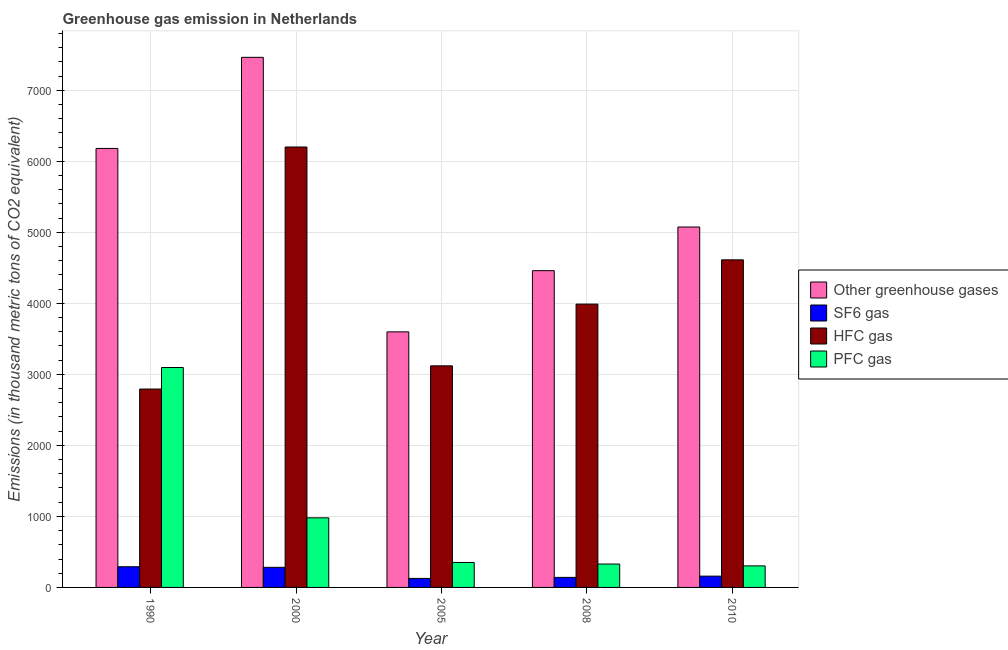Are the number of bars per tick equal to the number of legend labels?
Your answer should be compact. Yes. Are the number of bars on each tick of the X-axis equal?
Your response must be concise. Yes. How many bars are there on the 3rd tick from the right?
Provide a succinct answer. 4. What is the label of the 3rd group of bars from the left?
Give a very brief answer. 2005. In how many cases, is the number of bars for a given year not equal to the number of legend labels?
Keep it short and to the point. 0. What is the emission of hfc gas in 2005?
Provide a succinct answer. 3119.5. Across all years, what is the maximum emission of greenhouse gases?
Make the answer very short. 7462.9. Across all years, what is the minimum emission of hfc gas?
Your response must be concise. 2792.9. In which year was the emission of greenhouse gases maximum?
Your answer should be compact. 2000. In which year was the emission of sf6 gas minimum?
Offer a very short reply. 2005. What is the total emission of sf6 gas in the graph?
Keep it short and to the point. 1001.6. What is the difference between the emission of sf6 gas in 2000 and that in 2005?
Keep it short and to the point. 156.1. What is the difference between the emission of sf6 gas in 2005 and the emission of greenhouse gases in 2010?
Your answer should be compact. -32.1. What is the average emission of greenhouse gases per year?
Keep it short and to the point. 5354.9. In the year 2005, what is the difference between the emission of pfc gas and emission of hfc gas?
Offer a terse response. 0. What is the ratio of the emission of sf6 gas in 2000 to that in 2005?
Keep it short and to the point. 2.23. Is the emission of hfc gas in 2005 less than that in 2010?
Provide a short and direct response. Yes. Is the difference between the emission of pfc gas in 2005 and 2008 greater than the difference between the emission of greenhouse gases in 2005 and 2008?
Ensure brevity in your answer.  No. What is the difference between the highest and the second highest emission of pfc gas?
Your answer should be very brief. 2116.7. What is the difference between the highest and the lowest emission of hfc gas?
Keep it short and to the point. 3407.5. In how many years, is the emission of greenhouse gases greater than the average emission of greenhouse gases taken over all years?
Keep it short and to the point. 2. Is the sum of the emission of pfc gas in 2005 and 2010 greater than the maximum emission of sf6 gas across all years?
Your answer should be very brief. No. Is it the case that in every year, the sum of the emission of greenhouse gases and emission of hfc gas is greater than the sum of emission of pfc gas and emission of sf6 gas?
Offer a terse response. Yes. What does the 2nd bar from the left in 2010 represents?
Keep it short and to the point. SF6 gas. What does the 4th bar from the right in 2008 represents?
Your answer should be very brief. Other greenhouse gases. Are all the bars in the graph horizontal?
Ensure brevity in your answer.  No. How many years are there in the graph?
Keep it short and to the point. 5. What is the difference between two consecutive major ticks on the Y-axis?
Provide a succinct answer. 1000. Are the values on the major ticks of Y-axis written in scientific E-notation?
Provide a succinct answer. No. Does the graph contain grids?
Your answer should be compact. Yes. Where does the legend appear in the graph?
Your answer should be compact. Center right. How are the legend labels stacked?
Provide a succinct answer. Vertical. What is the title of the graph?
Give a very brief answer. Greenhouse gas emission in Netherlands. What is the label or title of the Y-axis?
Offer a very short reply. Emissions (in thousand metric tons of CO2 equivalent). What is the Emissions (in thousand metric tons of CO2 equivalent) in Other greenhouse gases in 1990?
Your answer should be very brief. 6180.4. What is the Emissions (in thousand metric tons of CO2 equivalent) of SF6 gas in 1990?
Provide a short and direct response. 291.3. What is the Emissions (in thousand metric tons of CO2 equivalent) of HFC gas in 1990?
Offer a very short reply. 2792.9. What is the Emissions (in thousand metric tons of CO2 equivalent) in PFC gas in 1990?
Offer a terse response. 3096.2. What is the Emissions (in thousand metric tons of CO2 equivalent) in Other greenhouse gases in 2000?
Give a very brief answer. 7462.9. What is the Emissions (in thousand metric tons of CO2 equivalent) of SF6 gas in 2000?
Give a very brief answer. 283. What is the Emissions (in thousand metric tons of CO2 equivalent) of HFC gas in 2000?
Provide a short and direct response. 6200.4. What is the Emissions (in thousand metric tons of CO2 equivalent) in PFC gas in 2000?
Offer a very short reply. 979.5. What is the Emissions (in thousand metric tons of CO2 equivalent) of Other greenhouse gases in 2005?
Your response must be concise. 3597.8. What is the Emissions (in thousand metric tons of CO2 equivalent) of SF6 gas in 2005?
Offer a very short reply. 126.9. What is the Emissions (in thousand metric tons of CO2 equivalent) of HFC gas in 2005?
Provide a short and direct response. 3119.5. What is the Emissions (in thousand metric tons of CO2 equivalent) in PFC gas in 2005?
Provide a succinct answer. 351.4. What is the Emissions (in thousand metric tons of CO2 equivalent) of Other greenhouse gases in 2008?
Give a very brief answer. 4459.4. What is the Emissions (in thousand metric tons of CO2 equivalent) of SF6 gas in 2008?
Give a very brief answer. 141.4. What is the Emissions (in thousand metric tons of CO2 equivalent) in HFC gas in 2008?
Offer a terse response. 3988.8. What is the Emissions (in thousand metric tons of CO2 equivalent) of PFC gas in 2008?
Ensure brevity in your answer.  329.2. What is the Emissions (in thousand metric tons of CO2 equivalent) in Other greenhouse gases in 2010?
Provide a succinct answer. 5074. What is the Emissions (in thousand metric tons of CO2 equivalent) in SF6 gas in 2010?
Offer a very short reply. 159. What is the Emissions (in thousand metric tons of CO2 equivalent) of HFC gas in 2010?
Your response must be concise. 4612. What is the Emissions (in thousand metric tons of CO2 equivalent) in PFC gas in 2010?
Provide a succinct answer. 303. Across all years, what is the maximum Emissions (in thousand metric tons of CO2 equivalent) in Other greenhouse gases?
Your answer should be very brief. 7462.9. Across all years, what is the maximum Emissions (in thousand metric tons of CO2 equivalent) in SF6 gas?
Your response must be concise. 291.3. Across all years, what is the maximum Emissions (in thousand metric tons of CO2 equivalent) of HFC gas?
Your response must be concise. 6200.4. Across all years, what is the maximum Emissions (in thousand metric tons of CO2 equivalent) in PFC gas?
Offer a very short reply. 3096.2. Across all years, what is the minimum Emissions (in thousand metric tons of CO2 equivalent) of Other greenhouse gases?
Offer a terse response. 3597.8. Across all years, what is the minimum Emissions (in thousand metric tons of CO2 equivalent) of SF6 gas?
Your response must be concise. 126.9. Across all years, what is the minimum Emissions (in thousand metric tons of CO2 equivalent) in HFC gas?
Make the answer very short. 2792.9. Across all years, what is the minimum Emissions (in thousand metric tons of CO2 equivalent) in PFC gas?
Keep it short and to the point. 303. What is the total Emissions (in thousand metric tons of CO2 equivalent) of Other greenhouse gases in the graph?
Make the answer very short. 2.68e+04. What is the total Emissions (in thousand metric tons of CO2 equivalent) of SF6 gas in the graph?
Make the answer very short. 1001.6. What is the total Emissions (in thousand metric tons of CO2 equivalent) in HFC gas in the graph?
Give a very brief answer. 2.07e+04. What is the total Emissions (in thousand metric tons of CO2 equivalent) of PFC gas in the graph?
Provide a short and direct response. 5059.3. What is the difference between the Emissions (in thousand metric tons of CO2 equivalent) in Other greenhouse gases in 1990 and that in 2000?
Your answer should be compact. -1282.5. What is the difference between the Emissions (in thousand metric tons of CO2 equivalent) of SF6 gas in 1990 and that in 2000?
Your answer should be very brief. 8.3. What is the difference between the Emissions (in thousand metric tons of CO2 equivalent) in HFC gas in 1990 and that in 2000?
Keep it short and to the point. -3407.5. What is the difference between the Emissions (in thousand metric tons of CO2 equivalent) in PFC gas in 1990 and that in 2000?
Give a very brief answer. 2116.7. What is the difference between the Emissions (in thousand metric tons of CO2 equivalent) in Other greenhouse gases in 1990 and that in 2005?
Your response must be concise. 2582.6. What is the difference between the Emissions (in thousand metric tons of CO2 equivalent) in SF6 gas in 1990 and that in 2005?
Keep it short and to the point. 164.4. What is the difference between the Emissions (in thousand metric tons of CO2 equivalent) in HFC gas in 1990 and that in 2005?
Provide a succinct answer. -326.6. What is the difference between the Emissions (in thousand metric tons of CO2 equivalent) of PFC gas in 1990 and that in 2005?
Provide a short and direct response. 2744.8. What is the difference between the Emissions (in thousand metric tons of CO2 equivalent) in Other greenhouse gases in 1990 and that in 2008?
Your answer should be compact. 1721. What is the difference between the Emissions (in thousand metric tons of CO2 equivalent) of SF6 gas in 1990 and that in 2008?
Keep it short and to the point. 149.9. What is the difference between the Emissions (in thousand metric tons of CO2 equivalent) of HFC gas in 1990 and that in 2008?
Offer a terse response. -1195.9. What is the difference between the Emissions (in thousand metric tons of CO2 equivalent) of PFC gas in 1990 and that in 2008?
Provide a short and direct response. 2767. What is the difference between the Emissions (in thousand metric tons of CO2 equivalent) of Other greenhouse gases in 1990 and that in 2010?
Provide a succinct answer. 1106.4. What is the difference between the Emissions (in thousand metric tons of CO2 equivalent) in SF6 gas in 1990 and that in 2010?
Ensure brevity in your answer.  132.3. What is the difference between the Emissions (in thousand metric tons of CO2 equivalent) of HFC gas in 1990 and that in 2010?
Give a very brief answer. -1819.1. What is the difference between the Emissions (in thousand metric tons of CO2 equivalent) of PFC gas in 1990 and that in 2010?
Provide a short and direct response. 2793.2. What is the difference between the Emissions (in thousand metric tons of CO2 equivalent) in Other greenhouse gases in 2000 and that in 2005?
Offer a very short reply. 3865.1. What is the difference between the Emissions (in thousand metric tons of CO2 equivalent) in SF6 gas in 2000 and that in 2005?
Your answer should be very brief. 156.1. What is the difference between the Emissions (in thousand metric tons of CO2 equivalent) in HFC gas in 2000 and that in 2005?
Keep it short and to the point. 3080.9. What is the difference between the Emissions (in thousand metric tons of CO2 equivalent) of PFC gas in 2000 and that in 2005?
Offer a very short reply. 628.1. What is the difference between the Emissions (in thousand metric tons of CO2 equivalent) of Other greenhouse gases in 2000 and that in 2008?
Your response must be concise. 3003.5. What is the difference between the Emissions (in thousand metric tons of CO2 equivalent) in SF6 gas in 2000 and that in 2008?
Your answer should be compact. 141.6. What is the difference between the Emissions (in thousand metric tons of CO2 equivalent) in HFC gas in 2000 and that in 2008?
Your response must be concise. 2211.6. What is the difference between the Emissions (in thousand metric tons of CO2 equivalent) in PFC gas in 2000 and that in 2008?
Make the answer very short. 650.3. What is the difference between the Emissions (in thousand metric tons of CO2 equivalent) in Other greenhouse gases in 2000 and that in 2010?
Offer a terse response. 2388.9. What is the difference between the Emissions (in thousand metric tons of CO2 equivalent) of SF6 gas in 2000 and that in 2010?
Make the answer very short. 124. What is the difference between the Emissions (in thousand metric tons of CO2 equivalent) in HFC gas in 2000 and that in 2010?
Provide a short and direct response. 1588.4. What is the difference between the Emissions (in thousand metric tons of CO2 equivalent) of PFC gas in 2000 and that in 2010?
Your response must be concise. 676.5. What is the difference between the Emissions (in thousand metric tons of CO2 equivalent) of Other greenhouse gases in 2005 and that in 2008?
Your answer should be compact. -861.6. What is the difference between the Emissions (in thousand metric tons of CO2 equivalent) of SF6 gas in 2005 and that in 2008?
Offer a terse response. -14.5. What is the difference between the Emissions (in thousand metric tons of CO2 equivalent) of HFC gas in 2005 and that in 2008?
Your answer should be compact. -869.3. What is the difference between the Emissions (in thousand metric tons of CO2 equivalent) of Other greenhouse gases in 2005 and that in 2010?
Your answer should be very brief. -1476.2. What is the difference between the Emissions (in thousand metric tons of CO2 equivalent) of SF6 gas in 2005 and that in 2010?
Keep it short and to the point. -32.1. What is the difference between the Emissions (in thousand metric tons of CO2 equivalent) of HFC gas in 2005 and that in 2010?
Ensure brevity in your answer.  -1492.5. What is the difference between the Emissions (in thousand metric tons of CO2 equivalent) in PFC gas in 2005 and that in 2010?
Your response must be concise. 48.4. What is the difference between the Emissions (in thousand metric tons of CO2 equivalent) in Other greenhouse gases in 2008 and that in 2010?
Make the answer very short. -614.6. What is the difference between the Emissions (in thousand metric tons of CO2 equivalent) of SF6 gas in 2008 and that in 2010?
Your answer should be compact. -17.6. What is the difference between the Emissions (in thousand metric tons of CO2 equivalent) in HFC gas in 2008 and that in 2010?
Your answer should be very brief. -623.2. What is the difference between the Emissions (in thousand metric tons of CO2 equivalent) of PFC gas in 2008 and that in 2010?
Offer a very short reply. 26.2. What is the difference between the Emissions (in thousand metric tons of CO2 equivalent) in Other greenhouse gases in 1990 and the Emissions (in thousand metric tons of CO2 equivalent) in SF6 gas in 2000?
Offer a very short reply. 5897.4. What is the difference between the Emissions (in thousand metric tons of CO2 equivalent) of Other greenhouse gases in 1990 and the Emissions (in thousand metric tons of CO2 equivalent) of HFC gas in 2000?
Your answer should be compact. -20. What is the difference between the Emissions (in thousand metric tons of CO2 equivalent) of Other greenhouse gases in 1990 and the Emissions (in thousand metric tons of CO2 equivalent) of PFC gas in 2000?
Keep it short and to the point. 5200.9. What is the difference between the Emissions (in thousand metric tons of CO2 equivalent) in SF6 gas in 1990 and the Emissions (in thousand metric tons of CO2 equivalent) in HFC gas in 2000?
Ensure brevity in your answer.  -5909.1. What is the difference between the Emissions (in thousand metric tons of CO2 equivalent) of SF6 gas in 1990 and the Emissions (in thousand metric tons of CO2 equivalent) of PFC gas in 2000?
Provide a short and direct response. -688.2. What is the difference between the Emissions (in thousand metric tons of CO2 equivalent) of HFC gas in 1990 and the Emissions (in thousand metric tons of CO2 equivalent) of PFC gas in 2000?
Offer a very short reply. 1813.4. What is the difference between the Emissions (in thousand metric tons of CO2 equivalent) of Other greenhouse gases in 1990 and the Emissions (in thousand metric tons of CO2 equivalent) of SF6 gas in 2005?
Your response must be concise. 6053.5. What is the difference between the Emissions (in thousand metric tons of CO2 equivalent) of Other greenhouse gases in 1990 and the Emissions (in thousand metric tons of CO2 equivalent) of HFC gas in 2005?
Your answer should be very brief. 3060.9. What is the difference between the Emissions (in thousand metric tons of CO2 equivalent) of Other greenhouse gases in 1990 and the Emissions (in thousand metric tons of CO2 equivalent) of PFC gas in 2005?
Offer a very short reply. 5829. What is the difference between the Emissions (in thousand metric tons of CO2 equivalent) of SF6 gas in 1990 and the Emissions (in thousand metric tons of CO2 equivalent) of HFC gas in 2005?
Offer a very short reply. -2828.2. What is the difference between the Emissions (in thousand metric tons of CO2 equivalent) in SF6 gas in 1990 and the Emissions (in thousand metric tons of CO2 equivalent) in PFC gas in 2005?
Make the answer very short. -60.1. What is the difference between the Emissions (in thousand metric tons of CO2 equivalent) of HFC gas in 1990 and the Emissions (in thousand metric tons of CO2 equivalent) of PFC gas in 2005?
Make the answer very short. 2441.5. What is the difference between the Emissions (in thousand metric tons of CO2 equivalent) of Other greenhouse gases in 1990 and the Emissions (in thousand metric tons of CO2 equivalent) of SF6 gas in 2008?
Provide a succinct answer. 6039. What is the difference between the Emissions (in thousand metric tons of CO2 equivalent) of Other greenhouse gases in 1990 and the Emissions (in thousand metric tons of CO2 equivalent) of HFC gas in 2008?
Your answer should be very brief. 2191.6. What is the difference between the Emissions (in thousand metric tons of CO2 equivalent) of Other greenhouse gases in 1990 and the Emissions (in thousand metric tons of CO2 equivalent) of PFC gas in 2008?
Offer a very short reply. 5851.2. What is the difference between the Emissions (in thousand metric tons of CO2 equivalent) in SF6 gas in 1990 and the Emissions (in thousand metric tons of CO2 equivalent) in HFC gas in 2008?
Your answer should be compact. -3697.5. What is the difference between the Emissions (in thousand metric tons of CO2 equivalent) in SF6 gas in 1990 and the Emissions (in thousand metric tons of CO2 equivalent) in PFC gas in 2008?
Your response must be concise. -37.9. What is the difference between the Emissions (in thousand metric tons of CO2 equivalent) of HFC gas in 1990 and the Emissions (in thousand metric tons of CO2 equivalent) of PFC gas in 2008?
Give a very brief answer. 2463.7. What is the difference between the Emissions (in thousand metric tons of CO2 equivalent) in Other greenhouse gases in 1990 and the Emissions (in thousand metric tons of CO2 equivalent) in SF6 gas in 2010?
Your answer should be compact. 6021.4. What is the difference between the Emissions (in thousand metric tons of CO2 equivalent) of Other greenhouse gases in 1990 and the Emissions (in thousand metric tons of CO2 equivalent) of HFC gas in 2010?
Offer a terse response. 1568.4. What is the difference between the Emissions (in thousand metric tons of CO2 equivalent) in Other greenhouse gases in 1990 and the Emissions (in thousand metric tons of CO2 equivalent) in PFC gas in 2010?
Your answer should be very brief. 5877.4. What is the difference between the Emissions (in thousand metric tons of CO2 equivalent) of SF6 gas in 1990 and the Emissions (in thousand metric tons of CO2 equivalent) of HFC gas in 2010?
Make the answer very short. -4320.7. What is the difference between the Emissions (in thousand metric tons of CO2 equivalent) in SF6 gas in 1990 and the Emissions (in thousand metric tons of CO2 equivalent) in PFC gas in 2010?
Give a very brief answer. -11.7. What is the difference between the Emissions (in thousand metric tons of CO2 equivalent) of HFC gas in 1990 and the Emissions (in thousand metric tons of CO2 equivalent) of PFC gas in 2010?
Make the answer very short. 2489.9. What is the difference between the Emissions (in thousand metric tons of CO2 equivalent) in Other greenhouse gases in 2000 and the Emissions (in thousand metric tons of CO2 equivalent) in SF6 gas in 2005?
Your answer should be compact. 7336. What is the difference between the Emissions (in thousand metric tons of CO2 equivalent) in Other greenhouse gases in 2000 and the Emissions (in thousand metric tons of CO2 equivalent) in HFC gas in 2005?
Give a very brief answer. 4343.4. What is the difference between the Emissions (in thousand metric tons of CO2 equivalent) of Other greenhouse gases in 2000 and the Emissions (in thousand metric tons of CO2 equivalent) of PFC gas in 2005?
Ensure brevity in your answer.  7111.5. What is the difference between the Emissions (in thousand metric tons of CO2 equivalent) in SF6 gas in 2000 and the Emissions (in thousand metric tons of CO2 equivalent) in HFC gas in 2005?
Your answer should be very brief. -2836.5. What is the difference between the Emissions (in thousand metric tons of CO2 equivalent) in SF6 gas in 2000 and the Emissions (in thousand metric tons of CO2 equivalent) in PFC gas in 2005?
Your answer should be very brief. -68.4. What is the difference between the Emissions (in thousand metric tons of CO2 equivalent) in HFC gas in 2000 and the Emissions (in thousand metric tons of CO2 equivalent) in PFC gas in 2005?
Offer a terse response. 5849. What is the difference between the Emissions (in thousand metric tons of CO2 equivalent) of Other greenhouse gases in 2000 and the Emissions (in thousand metric tons of CO2 equivalent) of SF6 gas in 2008?
Provide a short and direct response. 7321.5. What is the difference between the Emissions (in thousand metric tons of CO2 equivalent) of Other greenhouse gases in 2000 and the Emissions (in thousand metric tons of CO2 equivalent) of HFC gas in 2008?
Keep it short and to the point. 3474.1. What is the difference between the Emissions (in thousand metric tons of CO2 equivalent) of Other greenhouse gases in 2000 and the Emissions (in thousand metric tons of CO2 equivalent) of PFC gas in 2008?
Make the answer very short. 7133.7. What is the difference between the Emissions (in thousand metric tons of CO2 equivalent) of SF6 gas in 2000 and the Emissions (in thousand metric tons of CO2 equivalent) of HFC gas in 2008?
Offer a terse response. -3705.8. What is the difference between the Emissions (in thousand metric tons of CO2 equivalent) in SF6 gas in 2000 and the Emissions (in thousand metric tons of CO2 equivalent) in PFC gas in 2008?
Offer a very short reply. -46.2. What is the difference between the Emissions (in thousand metric tons of CO2 equivalent) of HFC gas in 2000 and the Emissions (in thousand metric tons of CO2 equivalent) of PFC gas in 2008?
Your response must be concise. 5871.2. What is the difference between the Emissions (in thousand metric tons of CO2 equivalent) in Other greenhouse gases in 2000 and the Emissions (in thousand metric tons of CO2 equivalent) in SF6 gas in 2010?
Keep it short and to the point. 7303.9. What is the difference between the Emissions (in thousand metric tons of CO2 equivalent) in Other greenhouse gases in 2000 and the Emissions (in thousand metric tons of CO2 equivalent) in HFC gas in 2010?
Your answer should be compact. 2850.9. What is the difference between the Emissions (in thousand metric tons of CO2 equivalent) in Other greenhouse gases in 2000 and the Emissions (in thousand metric tons of CO2 equivalent) in PFC gas in 2010?
Offer a terse response. 7159.9. What is the difference between the Emissions (in thousand metric tons of CO2 equivalent) of SF6 gas in 2000 and the Emissions (in thousand metric tons of CO2 equivalent) of HFC gas in 2010?
Offer a very short reply. -4329. What is the difference between the Emissions (in thousand metric tons of CO2 equivalent) of SF6 gas in 2000 and the Emissions (in thousand metric tons of CO2 equivalent) of PFC gas in 2010?
Offer a very short reply. -20. What is the difference between the Emissions (in thousand metric tons of CO2 equivalent) in HFC gas in 2000 and the Emissions (in thousand metric tons of CO2 equivalent) in PFC gas in 2010?
Your answer should be very brief. 5897.4. What is the difference between the Emissions (in thousand metric tons of CO2 equivalent) of Other greenhouse gases in 2005 and the Emissions (in thousand metric tons of CO2 equivalent) of SF6 gas in 2008?
Your answer should be very brief. 3456.4. What is the difference between the Emissions (in thousand metric tons of CO2 equivalent) of Other greenhouse gases in 2005 and the Emissions (in thousand metric tons of CO2 equivalent) of HFC gas in 2008?
Offer a very short reply. -391. What is the difference between the Emissions (in thousand metric tons of CO2 equivalent) in Other greenhouse gases in 2005 and the Emissions (in thousand metric tons of CO2 equivalent) in PFC gas in 2008?
Your response must be concise. 3268.6. What is the difference between the Emissions (in thousand metric tons of CO2 equivalent) of SF6 gas in 2005 and the Emissions (in thousand metric tons of CO2 equivalent) of HFC gas in 2008?
Ensure brevity in your answer.  -3861.9. What is the difference between the Emissions (in thousand metric tons of CO2 equivalent) of SF6 gas in 2005 and the Emissions (in thousand metric tons of CO2 equivalent) of PFC gas in 2008?
Offer a terse response. -202.3. What is the difference between the Emissions (in thousand metric tons of CO2 equivalent) of HFC gas in 2005 and the Emissions (in thousand metric tons of CO2 equivalent) of PFC gas in 2008?
Offer a very short reply. 2790.3. What is the difference between the Emissions (in thousand metric tons of CO2 equivalent) of Other greenhouse gases in 2005 and the Emissions (in thousand metric tons of CO2 equivalent) of SF6 gas in 2010?
Offer a very short reply. 3438.8. What is the difference between the Emissions (in thousand metric tons of CO2 equivalent) of Other greenhouse gases in 2005 and the Emissions (in thousand metric tons of CO2 equivalent) of HFC gas in 2010?
Ensure brevity in your answer.  -1014.2. What is the difference between the Emissions (in thousand metric tons of CO2 equivalent) in Other greenhouse gases in 2005 and the Emissions (in thousand metric tons of CO2 equivalent) in PFC gas in 2010?
Give a very brief answer. 3294.8. What is the difference between the Emissions (in thousand metric tons of CO2 equivalent) in SF6 gas in 2005 and the Emissions (in thousand metric tons of CO2 equivalent) in HFC gas in 2010?
Keep it short and to the point. -4485.1. What is the difference between the Emissions (in thousand metric tons of CO2 equivalent) of SF6 gas in 2005 and the Emissions (in thousand metric tons of CO2 equivalent) of PFC gas in 2010?
Offer a very short reply. -176.1. What is the difference between the Emissions (in thousand metric tons of CO2 equivalent) of HFC gas in 2005 and the Emissions (in thousand metric tons of CO2 equivalent) of PFC gas in 2010?
Your answer should be compact. 2816.5. What is the difference between the Emissions (in thousand metric tons of CO2 equivalent) in Other greenhouse gases in 2008 and the Emissions (in thousand metric tons of CO2 equivalent) in SF6 gas in 2010?
Offer a terse response. 4300.4. What is the difference between the Emissions (in thousand metric tons of CO2 equivalent) in Other greenhouse gases in 2008 and the Emissions (in thousand metric tons of CO2 equivalent) in HFC gas in 2010?
Make the answer very short. -152.6. What is the difference between the Emissions (in thousand metric tons of CO2 equivalent) of Other greenhouse gases in 2008 and the Emissions (in thousand metric tons of CO2 equivalent) of PFC gas in 2010?
Offer a very short reply. 4156.4. What is the difference between the Emissions (in thousand metric tons of CO2 equivalent) in SF6 gas in 2008 and the Emissions (in thousand metric tons of CO2 equivalent) in HFC gas in 2010?
Offer a very short reply. -4470.6. What is the difference between the Emissions (in thousand metric tons of CO2 equivalent) of SF6 gas in 2008 and the Emissions (in thousand metric tons of CO2 equivalent) of PFC gas in 2010?
Your answer should be very brief. -161.6. What is the difference between the Emissions (in thousand metric tons of CO2 equivalent) in HFC gas in 2008 and the Emissions (in thousand metric tons of CO2 equivalent) in PFC gas in 2010?
Provide a succinct answer. 3685.8. What is the average Emissions (in thousand metric tons of CO2 equivalent) in Other greenhouse gases per year?
Offer a very short reply. 5354.9. What is the average Emissions (in thousand metric tons of CO2 equivalent) in SF6 gas per year?
Ensure brevity in your answer.  200.32. What is the average Emissions (in thousand metric tons of CO2 equivalent) in HFC gas per year?
Keep it short and to the point. 4142.72. What is the average Emissions (in thousand metric tons of CO2 equivalent) of PFC gas per year?
Your response must be concise. 1011.86. In the year 1990, what is the difference between the Emissions (in thousand metric tons of CO2 equivalent) of Other greenhouse gases and Emissions (in thousand metric tons of CO2 equivalent) of SF6 gas?
Offer a very short reply. 5889.1. In the year 1990, what is the difference between the Emissions (in thousand metric tons of CO2 equivalent) of Other greenhouse gases and Emissions (in thousand metric tons of CO2 equivalent) of HFC gas?
Provide a succinct answer. 3387.5. In the year 1990, what is the difference between the Emissions (in thousand metric tons of CO2 equivalent) of Other greenhouse gases and Emissions (in thousand metric tons of CO2 equivalent) of PFC gas?
Ensure brevity in your answer.  3084.2. In the year 1990, what is the difference between the Emissions (in thousand metric tons of CO2 equivalent) of SF6 gas and Emissions (in thousand metric tons of CO2 equivalent) of HFC gas?
Ensure brevity in your answer.  -2501.6. In the year 1990, what is the difference between the Emissions (in thousand metric tons of CO2 equivalent) of SF6 gas and Emissions (in thousand metric tons of CO2 equivalent) of PFC gas?
Your answer should be compact. -2804.9. In the year 1990, what is the difference between the Emissions (in thousand metric tons of CO2 equivalent) of HFC gas and Emissions (in thousand metric tons of CO2 equivalent) of PFC gas?
Your answer should be very brief. -303.3. In the year 2000, what is the difference between the Emissions (in thousand metric tons of CO2 equivalent) of Other greenhouse gases and Emissions (in thousand metric tons of CO2 equivalent) of SF6 gas?
Your answer should be compact. 7179.9. In the year 2000, what is the difference between the Emissions (in thousand metric tons of CO2 equivalent) of Other greenhouse gases and Emissions (in thousand metric tons of CO2 equivalent) of HFC gas?
Your answer should be compact. 1262.5. In the year 2000, what is the difference between the Emissions (in thousand metric tons of CO2 equivalent) of Other greenhouse gases and Emissions (in thousand metric tons of CO2 equivalent) of PFC gas?
Your answer should be compact. 6483.4. In the year 2000, what is the difference between the Emissions (in thousand metric tons of CO2 equivalent) of SF6 gas and Emissions (in thousand metric tons of CO2 equivalent) of HFC gas?
Make the answer very short. -5917.4. In the year 2000, what is the difference between the Emissions (in thousand metric tons of CO2 equivalent) of SF6 gas and Emissions (in thousand metric tons of CO2 equivalent) of PFC gas?
Your answer should be very brief. -696.5. In the year 2000, what is the difference between the Emissions (in thousand metric tons of CO2 equivalent) in HFC gas and Emissions (in thousand metric tons of CO2 equivalent) in PFC gas?
Offer a terse response. 5220.9. In the year 2005, what is the difference between the Emissions (in thousand metric tons of CO2 equivalent) of Other greenhouse gases and Emissions (in thousand metric tons of CO2 equivalent) of SF6 gas?
Provide a succinct answer. 3470.9. In the year 2005, what is the difference between the Emissions (in thousand metric tons of CO2 equivalent) in Other greenhouse gases and Emissions (in thousand metric tons of CO2 equivalent) in HFC gas?
Keep it short and to the point. 478.3. In the year 2005, what is the difference between the Emissions (in thousand metric tons of CO2 equivalent) of Other greenhouse gases and Emissions (in thousand metric tons of CO2 equivalent) of PFC gas?
Your answer should be very brief. 3246.4. In the year 2005, what is the difference between the Emissions (in thousand metric tons of CO2 equivalent) of SF6 gas and Emissions (in thousand metric tons of CO2 equivalent) of HFC gas?
Provide a short and direct response. -2992.6. In the year 2005, what is the difference between the Emissions (in thousand metric tons of CO2 equivalent) of SF6 gas and Emissions (in thousand metric tons of CO2 equivalent) of PFC gas?
Give a very brief answer. -224.5. In the year 2005, what is the difference between the Emissions (in thousand metric tons of CO2 equivalent) of HFC gas and Emissions (in thousand metric tons of CO2 equivalent) of PFC gas?
Your answer should be compact. 2768.1. In the year 2008, what is the difference between the Emissions (in thousand metric tons of CO2 equivalent) in Other greenhouse gases and Emissions (in thousand metric tons of CO2 equivalent) in SF6 gas?
Provide a short and direct response. 4318. In the year 2008, what is the difference between the Emissions (in thousand metric tons of CO2 equivalent) in Other greenhouse gases and Emissions (in thousand metric tons of CO2 equivalent) in HFC gas?
Provide a short and direct response. 470.6. In the year 2008, what is the difference between the Emissions (in thousand metric tons of CO2 equivalent) in Other greenhouse gases and Emissions (in thousand metric tons of CO2 equivalent) in PFC gas?
Your answer should be very brief. 4130.2. In the year 2008, what is the difference between the Emissions (in thousand metric tons of CO2 equivalent) of SF6 gas and Emissions (in thousand metric tons of CO2 equivalent) of HFC gas?
Keep it short and to the point. -3847.4. In the year 2008, what is the difference between the Emissions (in thousand metric tons of CO2 equivalent) of SF6 gas and Emissions (in thousand metric tons of CO2 equivalent) of PFC gas?
Give a very brief answer. -187.8. In the year 2008, what is the difference between the Emissions (in thousand metric tons of CO2 equivalent) in HFC gas and Emissions (in thousand metric tons of CO2 equivalent) in PFC gas?
Give a very brief answer. 3659.6. In the year 2010, what is the difference between the Emissions (in thousand metric tons of CO2 equivalent) in Other greenhouse gases and Emissions (in thousand metric tons of CO2 equivalent) in SF6 gas?
Your answer should be compact. 4915. In the year 2010, what is the difference between the Emissions (in thousand metric tons of CO2 equivalent) of Other greenhouse gases and Emissions (in thousand metric tons of CO2 equivalent) of HFC gas?
Keep it short and to the point. 462. In the year 2010, what is the difference between the Emissions (in thousand metric tons of CO2 equivalent) in Other greenhouse gases and Emissions (in thousand metric tons of CO2 equivalent) in PFC gas?
Your answer should be compact. 4771. In the year 2010, what is the difference between the Emissions (in thousand metric tons of CO2 equivalent) of SF6 gas and Emissions (in thousand metric tons of CO2 equivalent) of HFC gas?
Your response must be concise. -4453. In the year 2010, what is the difference between the Emissions (in thousand metric tons of CO2 equivalent) of SF6 gas and Emissions (in thousand metric tons of CO2 equivalent) of PFC gas?
Provide a short and direct response. -144. In the year 2010, what is the difference between the Emissions (in thousand metric tons of CO2 equivalent) in HFC gas and Emissions (in thousand metric tons of CO2 equivalent) in PFC gas?
Give a very brief answer. 4309. What is the ratio of the Emissions (in thousand metric tons of CO2 equivalent) of Other greenhouse gases in 1990 to that in 2000?
Offer a terse response. 0.83. What is the ratio of the Emissions (in thousand metric tons of CO2 equivalent) of SF6 gas in 1990 to that in 2000?
Give a very brief answer. 1.03. What is the ratio of the Emissions (in thousand metric tons of CO2 equivalent) in HFC gas in 1990 to that in 2000?
Ensure brevity in your answer.  0.45. What is the ratio of the Emissions (in thousand metric tons of CO2 equivalent) of PFC gas in 1990 to that in 2000?
Give a very brief answer. 3.16. What is the ratio of the Emissions (in thousand metric tons of CO2 equivalent) in Other greenhouse gases in 1990 to that in 2005?
Offer a terse response. 1.72. What is the ratio of the Emissions (in thousand metric tons of CO2 equivalent) of SF6 gas in 1990 to that in 2005?
Give a very brief answer. 2.3. What is the ratio of the Emissions (in thousand metric tons of CO2 equivalent) in HFC gas in 1990 to that in 2005?
Provide a succinct answer. 0.9. What is the ratio of the Emissions (in thousand metric tons of CO2 equivalent) of PFC gas in 1990 to that in 2005?
Give a very brief answer. 8.81. What is the ratio of the Emissions (in thousand metric tons of CO2 equivalent) of Other greenhouse gases in 1990 to that in 2008?
Provide a short and direct response. 1.39. What is the ratio of the Emissions (in thousand metric tons of CO2 equivalent) in SF6 gas in 1990 to that in 2008?
Give a very brief answer. 2.06. What is the ratio of the Emissions (in thousand metric tons of CO2 equivalent) in HFC gas in 1990 to that in 2008?
Offer a very short reply. 0.7. What is the ratio of the Emissions (in thousand metric tons of CO2 equivalent) of PFC gas in 1990 to that in 2008?
Make the answer very short. 9.41. What is the ratio of the Emissions (in thousand metric tons of CO2 equivalent) in Other greenhouse gases in 1990 to that in 2010?
Provide a succinct answer. 1.22. What is the ratio of the Emissions (in thousand metric tons of CO2 equivalent) of SF6 gas in 1990 to that in 2010?
Keep it short and to the point. 1.83. What is the ratio of the Emissions (in thousand metric tons of CO2 equivalent) in HFC gas in 1990 to that in 2010?
Make the answer very short. 0.61. What is the ratio of the Emissions (in thousand metric tons of CO2 equivalent) of PFC gas in 1990 to that in 2010?
Your response must be concise. 10.22. What is the ratio of the Emissions (in thousand metric tons of CO2 equivalent) of Other greenhouse gases in 2000 to that in 2005?
Provide a succinct answer. 2.07. What is the ratio of the Emissions (in thousand metric tons of CO2 equivalent) in SF6 gas in 2000 to that in 2005?
Your answer should be very brief. 2.23. What is the ratio of the Emissions (in thousand metric tons of CO2 equivalent) in HFC gas in 2000 to that in 2005?
Ensure brevity in your answer.  1.99. What is the ratio of the Emissions (in thousand metric tons of CO2 equivalent) in PFC gas in 2000 to that in 2005?
Your answer should be very brief. 2.79. What is the ratio of the Emissions (in thousand metric tons of CO2 equivalent) of Other greenhouse gases in 2000 to that in 2008?
Your answer should be compact. 1.67. What is the ratio of the Emissions (in thousand metric tons of CO2 equivalent) in SF6 gas in 2000 to that in 2008?
Ensure brevity in your answer.  2. What is the ratio of the Emissions (in thousand metric tons of CO2 equivalent) of HFC gas in 2000 to that in 2008?
Keep it short and to the point. 1.55. What is the ratio of the Emissions (in thousand metric tons of CO2 equivalent) in PFC gas in 2000 to that in 2008?
Give a very brief answer. 2.98. What is the ratio of the Emissions (in thousand metric tons of CO2 equivalent) in Other greenhouse gases in 2000 to that in 2010?
Give a very brief answer. 1.47. What is the ratio of the Emissions (in thousand metric tons of CO2 equivalent) of SF6 gas in 2000 to that in 2010?
Offer a terse response. 1.78. What is the ratio of the Emissions (in thousand metric tons of CO2 equivalent) in HFC gas in 2000 to that in 2010?
Provide a short and direct response. 1.34. What is the ratio of the Emissions (in thousand metric tons of CO2 equivalent) in PFC gas in 2000 to that in 2010?
Give a very brief answer. 3.23. What is the ratio of the Emissions (in thousand metric tons of CO2 equivalent) in Other greenhouse gases in 2005 to that in 2008?
Offer a very short reply. 0.81. What is the ratio of the Emissions (in thousand metric tons of CO2 equivalent) of SF6 gas in 2005 to that in 2008?
Ensure brevity in your answer.  0.9. What is the ratio of the Emissions (in thousand metric tons of CO2 equivalent) of HFC gas in 2005 to that in 2008?
Your response must be concise. 0.78. What is the ratio of the Emissions (in thousand metric tons of CO2 equivalent) in PFC gas in 2005 to that in 2008?
Give a very brief answer. 1.07. What is the ratio of the Emissions (in thousand metric tons of CO2 equivalent) of Other greenhouse gases in 2005 to that in 2010?
Your answer should be compact. 0.71. What is the ratio of the Emissions (in thousand metric tons of CO2 equivalent) in SF6 gas in 2005 to that in 2010?
Give a very brief answer. 0.8. What is the ratio of the Emissions (in thousand metric tons of CO2 equivalent) in HFC gas in 2005 to that in 2010?
Your response must be concise. 0.68. What is the ratio of the Emissions (in thousand metric tons of CO2 equivalent) in PFC gas in 2005 to that in 2010?
Your response must be concise. 1.16. What is the ratio of the Emissions (in thousand metric tons of CO2 equivalent) in Other greenhouse gases in 2008 to that in 2010?
Ensure brevity in your answer.  0.88. What is the ratio of the Emissions (in thousand metric tons of CO2 equivalent) in SF6 gas in 2008 to that in 2010?
Make the answer very short. 0.89. What is the ratio of the Emissions (in thousand metric tons of CO2 equivalent) in HFC gas in 2008 to that in 2010?
Provide a short and direct response. 0.86. What is the ratio of the Emissions (in thousand metric tons of CO2 equivalent) of PFC gas in 2008 to that in 2010?
Give a very brief answer. 1.09. What is the difference between the highest and the second highest Emissions (in thousand metric tons of CO2 equivalent) in Other greenhouse gases?
Offer a very short reply. 1282.5. What is the difference between the highest and the second highest Emissions (in thousand metric tons of CO2 equivalent) of HFC gas?
Make the answer very short. 1588.4. What is the difference between the highest and the second highest Emissions (in thousand metric tons of CO2 equivalent) in PFC gas?
Your answer should be compact. 2116.7. What is the difference between the highest and the lowest Emissions (in thousand metric tons of CO2 equivalent) in Other greenhouse gases?
Your response must be concise. 3865.1. What is the difference between the highest and the lowest Emissions (in thousand metric tons of CO2 equivalent) of SF6 gas?
Make the answer very short. 164.4. What is the difference between the highest and the lowest Emissions (in thousand metric tons of CO2 equivalent) in HFC gas?
Keep it short and to the point. 3407.5. What is the difference between the highest and the lowest Emissions (in thousand metric tons of CO2 equivalent) of PFC gas?
Offer a terse response. 2793.2. 